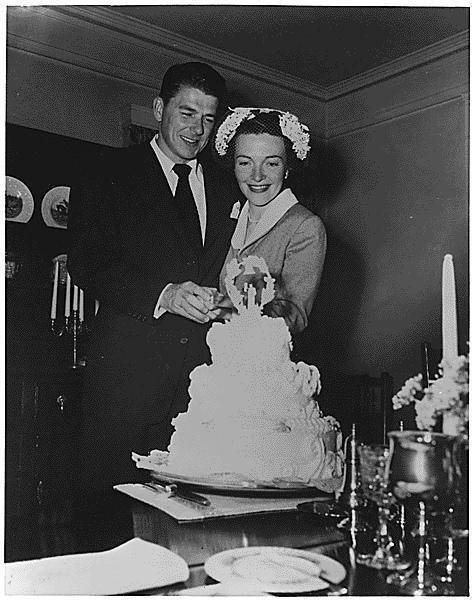How many people can you see?
Give a very brief answer. 2. 